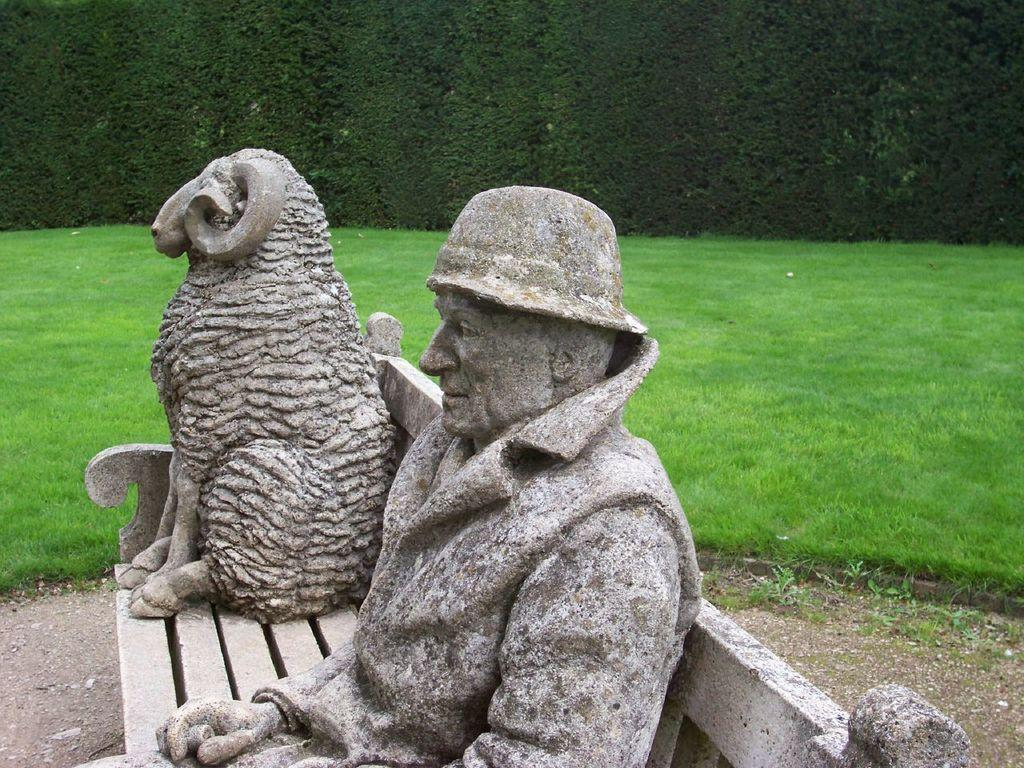What is on the bench in the image? There are sculptures on the bench. What type of vegetation can be seen in the background of the image? There is grass in the background of the image. What other feature is present in the background of the image? There is a hedge in the background of the image. What type of chin can be seen on the sculptures in the image? There are no chins visible on the sculptures in the image, as they are not human figures. Is there any cake present in the image? There is no cake present in the image. 